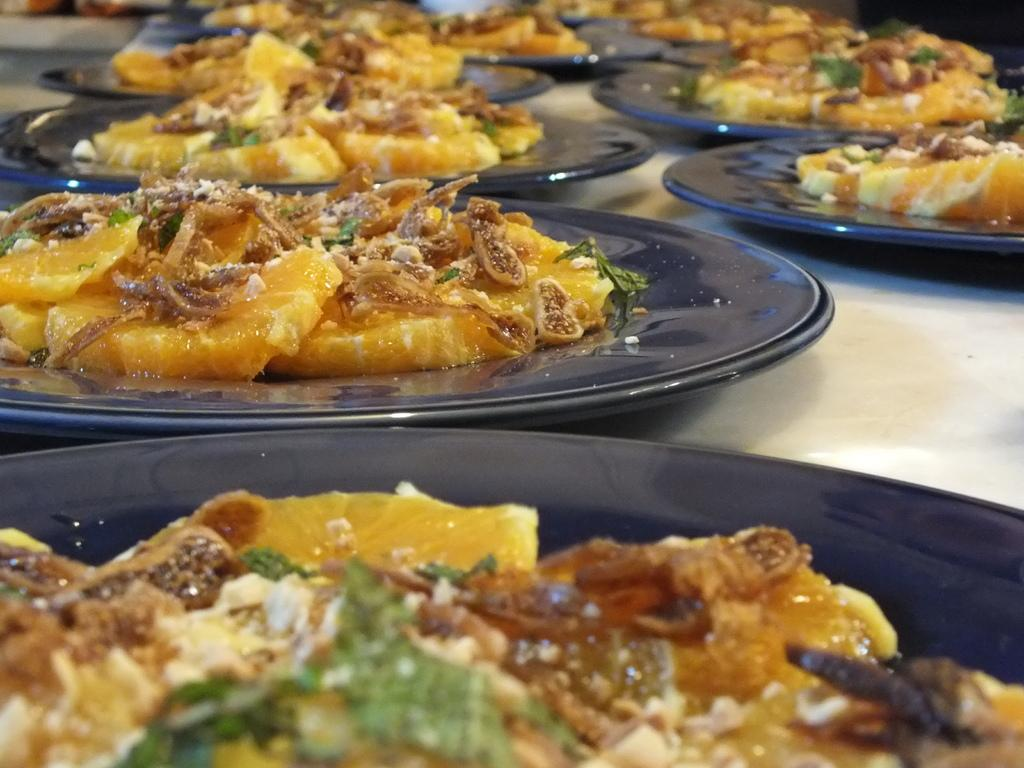What type of plates are used for the food in the image? The plates are black in the image. What is the color of the plates? The plates are black in the image. Where are the black plates placed in the image? The black plates are placed on a table top in the image. How many plates can be seen in the image? The provided facts do not specify the exact number of plates, but there is food on black plates in the image. Can you see the ocean in the background of the image? There is no mention of an ocean or any background in the provided facts, so it cannot be determined from the image. 